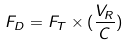<formula> <loc_0><loc_0><loc_500><loc_500>F _ { D } = F _ { T } \times ( \frac { V _ { R } } { C } )</formula> 